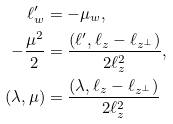Convert formula to latex. <formula><loc_0><loc_0><loc_500><loc_500>\ell ^ { \prime } _ { w } & = - \mu _ { w } , \\ - \frac { \mu ^ { 2 } } { 2 } & = \frac { ( \ell ^ { \prime } , \ell _ { z } - \ell _ { z ^ { \perp } } ) } { 2 \ell _ { z } ^ { 2 } } , \\ ( \lambda , \mu ) & = \frac { ( \lambda , \ell _ { z } - \ell _ { z ^ { \perp } } ) } { 2 \ell _ { z } ^ { 2 } }</formula> 